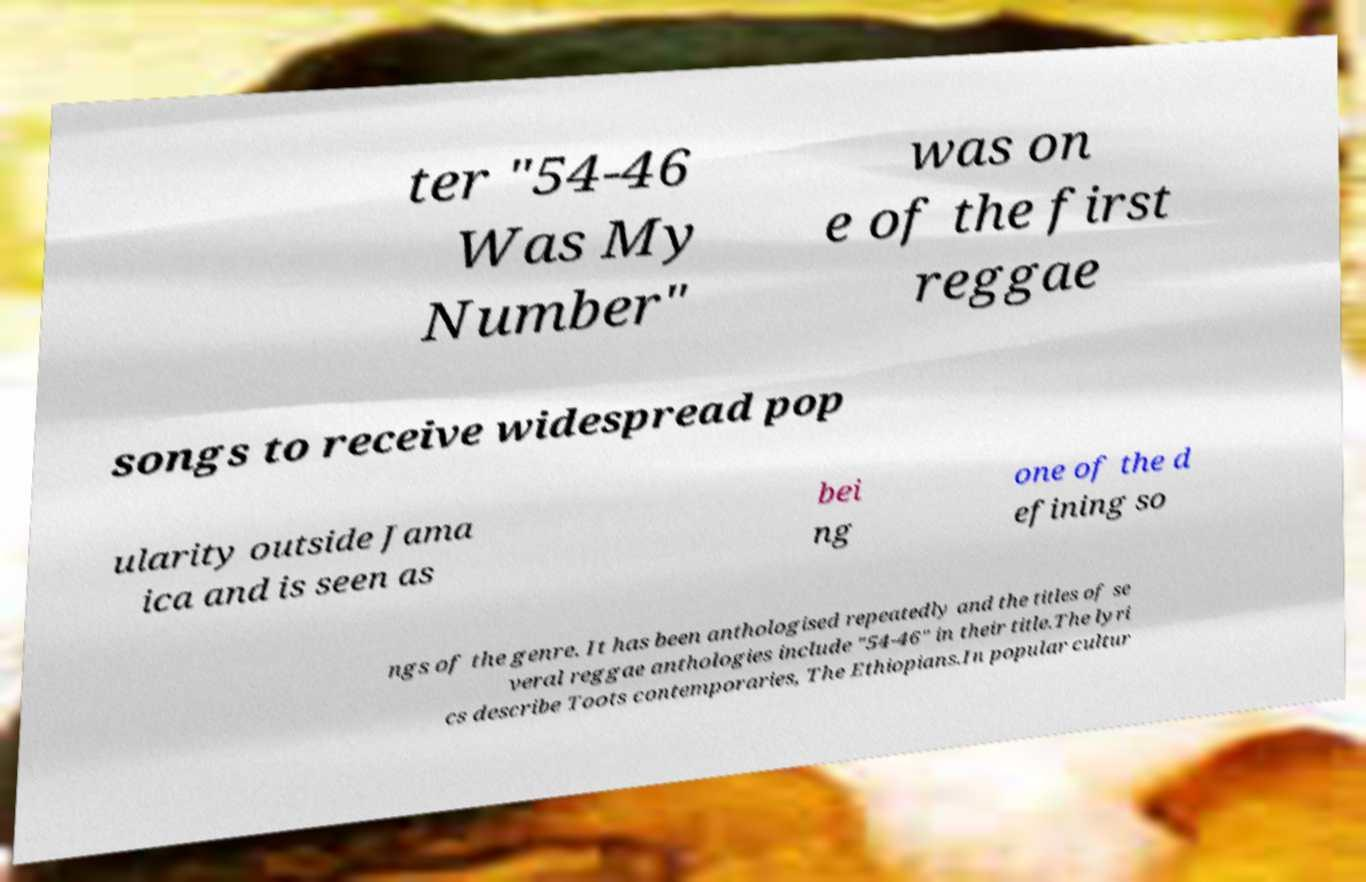Can you read and provide the text displayed in the image?This photo seems to have some interesting text. Can you extract and type it out for me? ter "54-46 Was My Number" was on e of the first reggae songs to receive widespread pop ularity outside Jama ica and is seen as bei ng one of the d efining so ngs of the genre. It has been anthologised repeatedly and the titles of se veral reggae anthologies include "54-46" in their title.The lyri cs describe Toots contemporaries, The Ethiopians.In popular cultur 